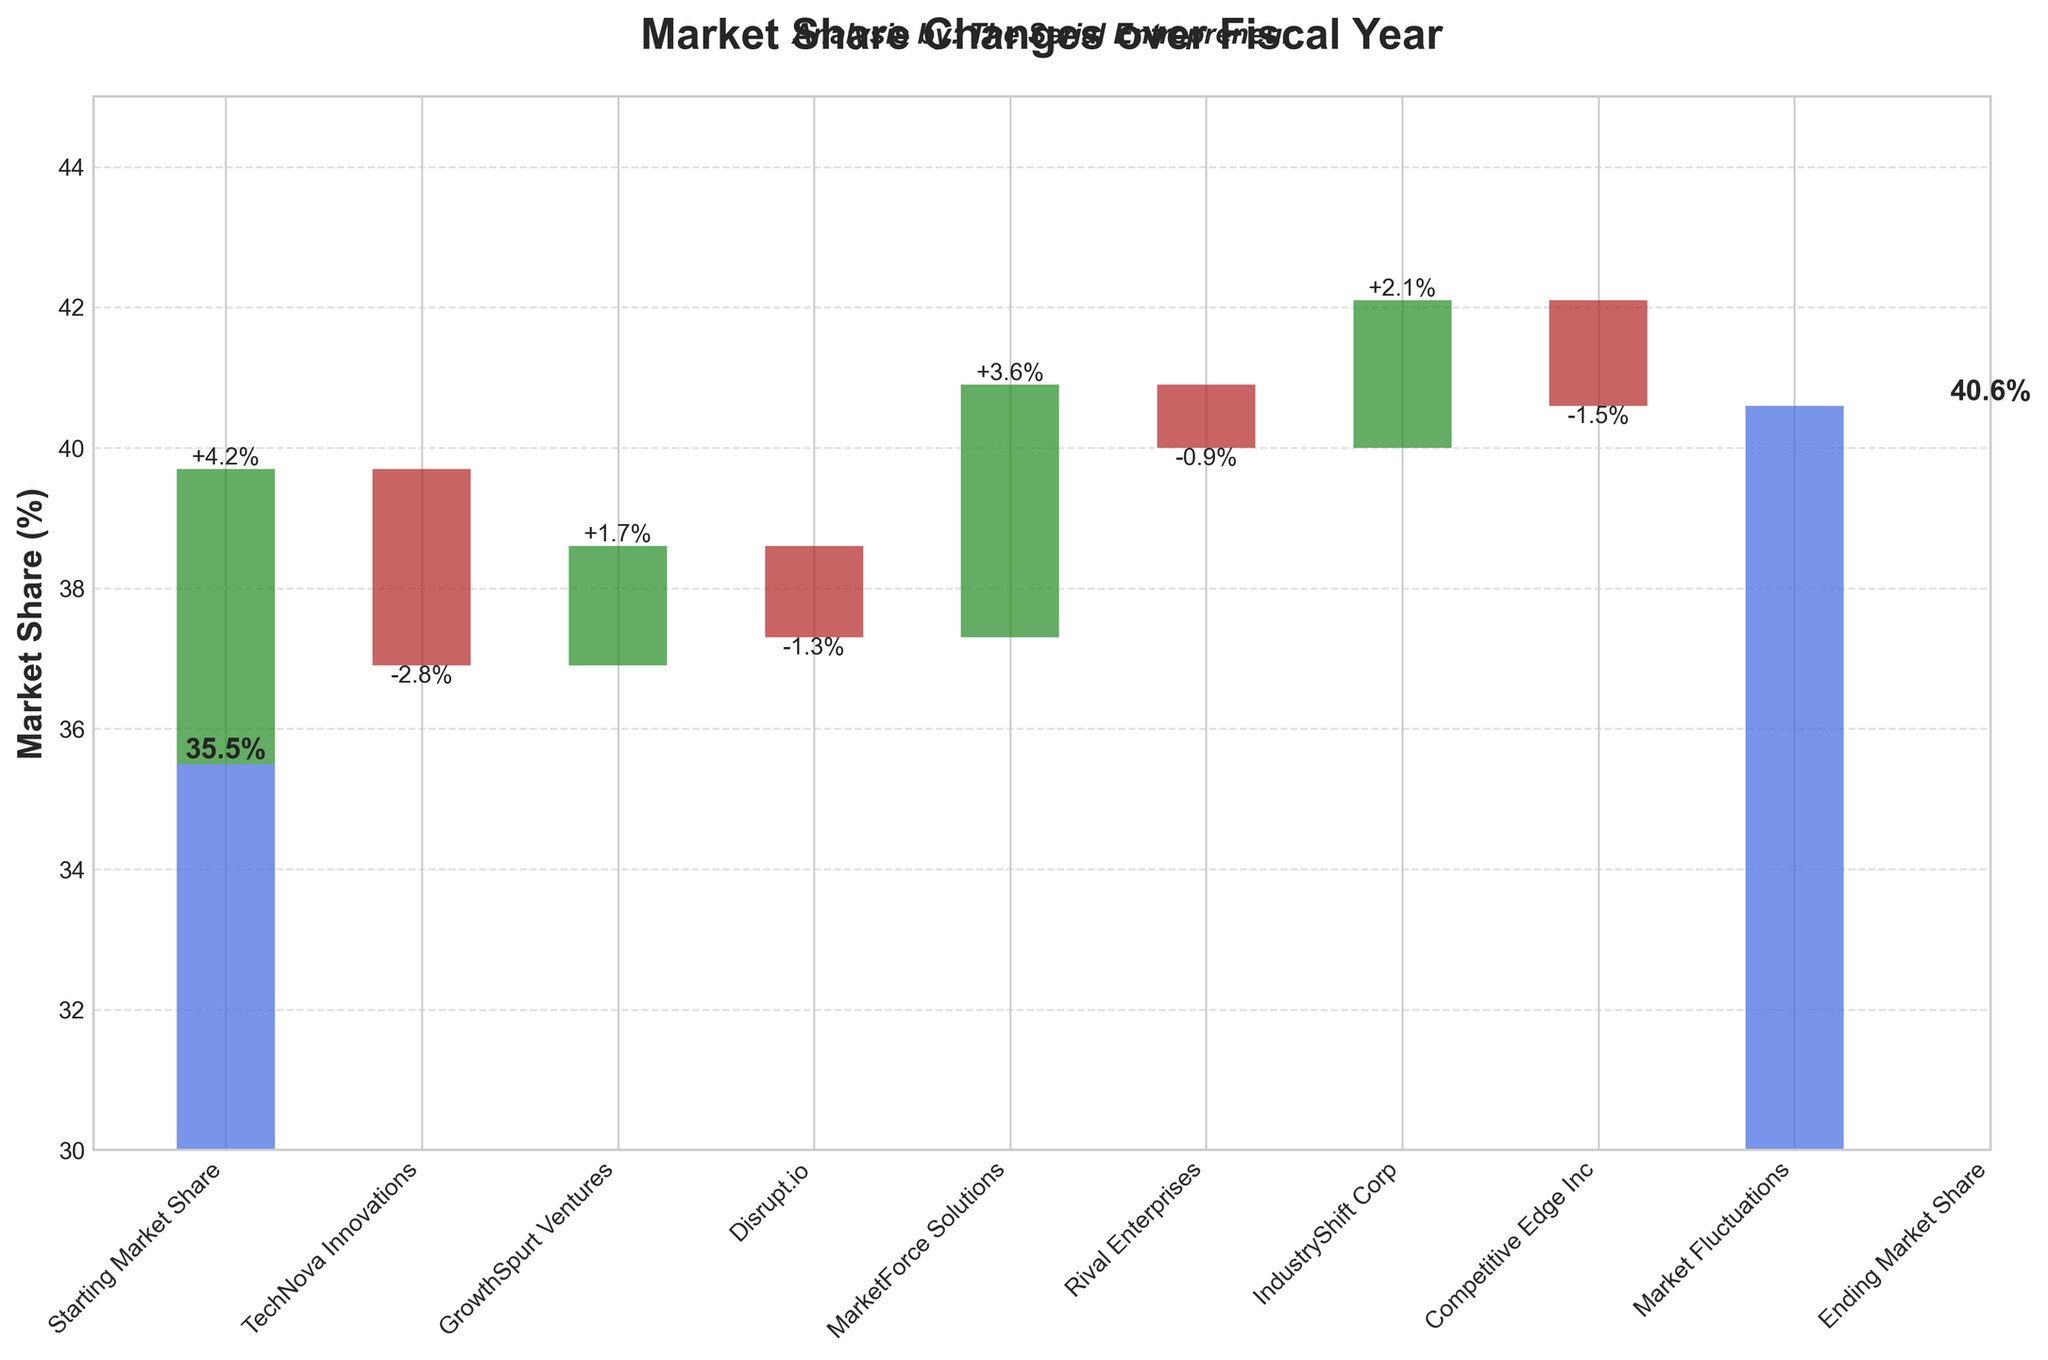What's the starting market share? The starting market share is labeled at the beginning of the waterfall chart with a specific value.
Answer: 35.5% What's the ending market share? The ending market share is shown at the end of the waterfall chart with a specific value.
Answer: 40.6% Which company contributed the most to the market share increase? Among the companies with positive changes, look for the highest positive bar value in green.
Answer: TechNova Innovations Which company resulted in the largest market share decrease? Among the companies with negative changes, find the largest negative bar value in red.
Answer: GrowthSpurt Ventures What was the net effect of the fluctuating companies (MarketFluctuations)? The net effect of MarketFluctuations is shown directly with a specific value.
Answer: -1.5% By how much did TechNova Innovations increase the market share? The label by the TechNova Innovations bar shows the specific positive change.
Answer: +4.2% What is the cumulative market share change before considering Market Fluctuations? Sum up the categories excluding Market Fluctuations: Starting Market Share + Contributions - Losses
Answer: 41.1% Comparing the contributions of Competitive Edge Inc and Rival Enterprises, which one was greater? By how much? Identify the bar heights and labels for both companies, then subtract the lower value from the higher value.
Answer: Rival Enterprises by 1.5% How many companies had a negative impact on the market share? Count the number of red bars, which indicate a negative change in market share.
Answer: 3 What is the total change in market share resulting from individual company contributions (excluding start and end)? Sum all the individual company values (both positive and negative).
Answer: +6.6% 